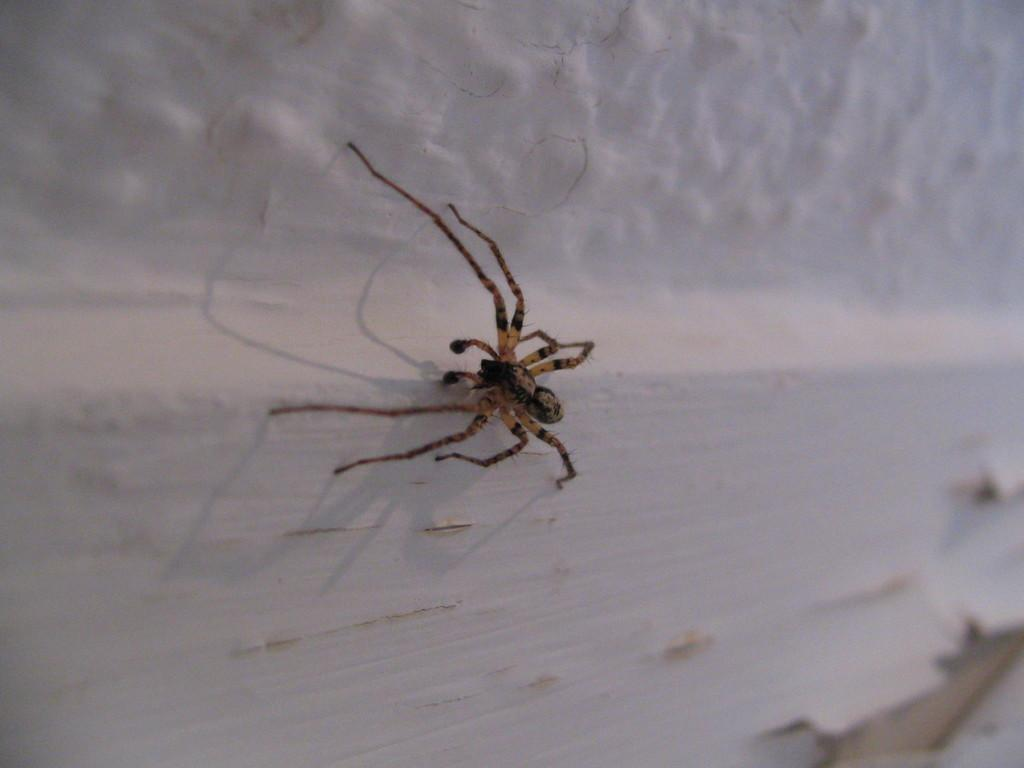What is: What is present in the image? There is a spider in the image. Where is the spider located? The spider is on the wall. What type of polish is the zebra using in the image? There is no zebra or polish present in the image; it only features a spider on the wall. 